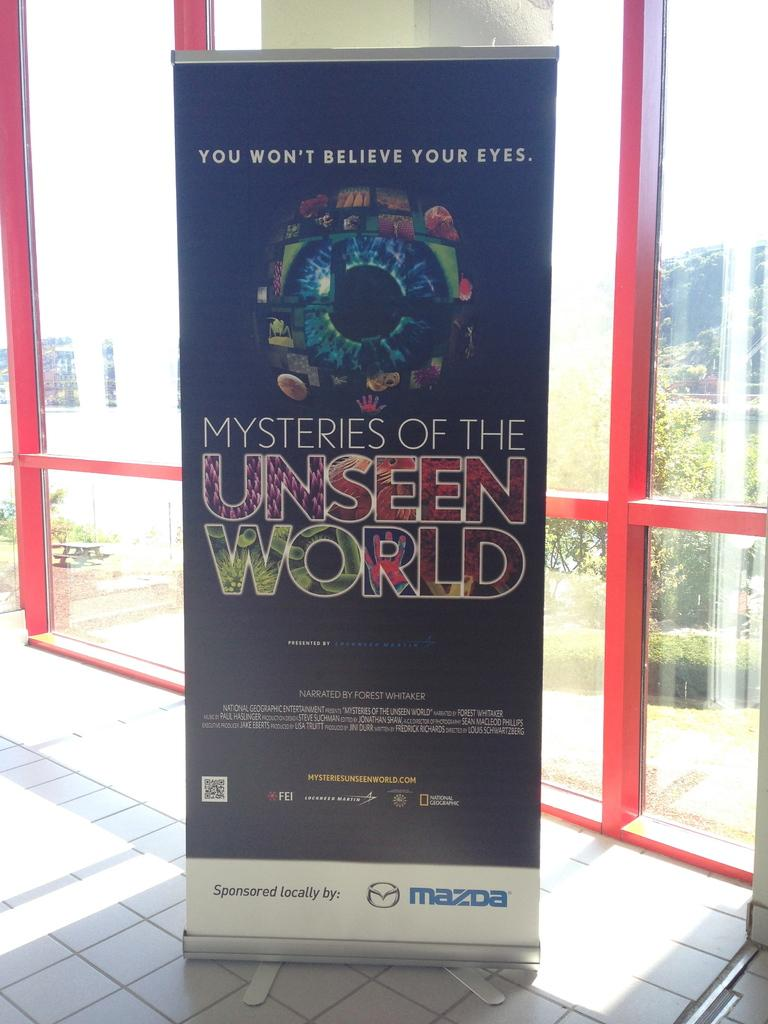Provide a one-sentence caption for the provided image. An advertisement displays an eyeball and is sponsored by Mazda. 